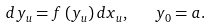<formula> <loc_0><loc_0><loc_500><loc_500>d y _ { u } = f \left ( y _ { u } \right ) d x _ { u } , \text { \ \ } y _ { 0 } = a .</formula> 